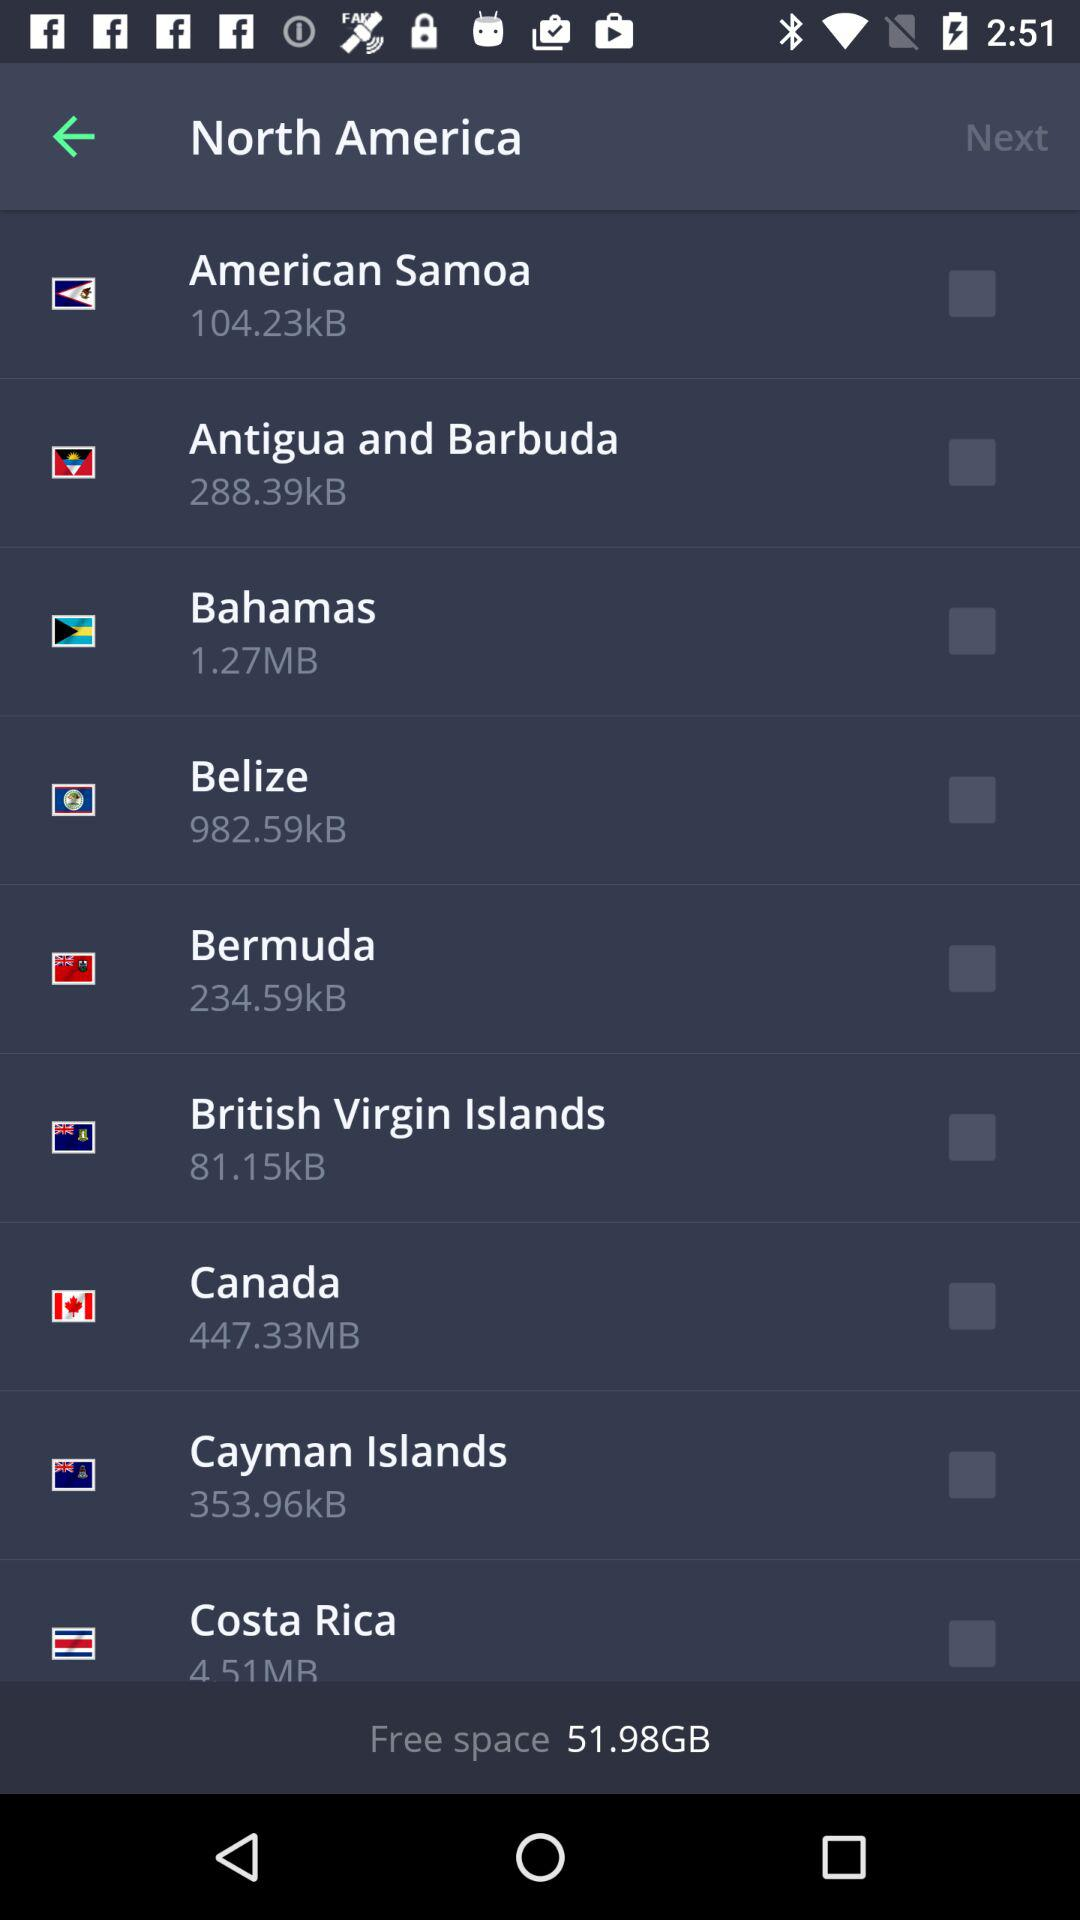What is the status of "Canada"? The status of "Canada" is "off". 